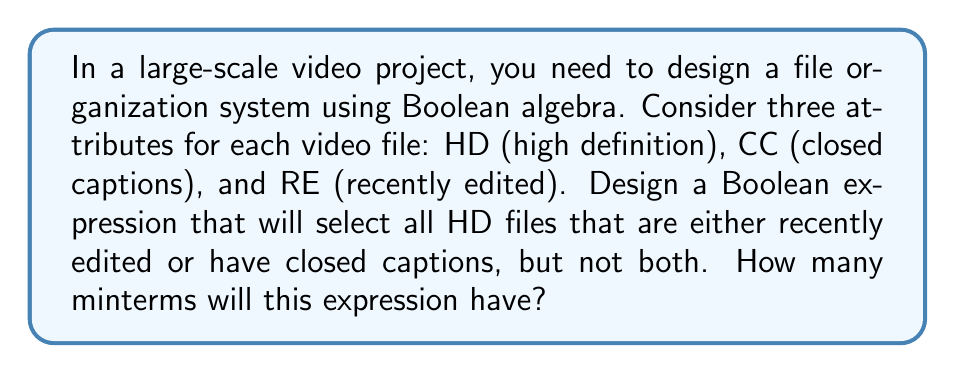Can you answer this question? Let's approach this step-by-step:

1) First, let's define our variables:
   HD: High Definition
   CC: Closed Captions
   RE: Recently Edited

2) We want files that are HD (so HD must be true) AND either RE or CC, but not both. This can be expressed as:

   $$ HD \cdot (RE \oplus CC) $$

   Where $\oplus$ represents the XOR operation.

3) To expand this, let's recall the XOR operation in terms of AND, OR, and NOT:

   $$ A \oplus B = (A \cdot \overline{B}) + (\overline{A} \cdot B) $$

4) Substituting this into our expression:

   $$ HD \cdot ((RE \cdot \overline{CC}) + (\overline{RE} \cdot CC)) $$

5) Expanding this using the distributive property:

   $$ (HD \cdot RE \cdot \overline{CC}) + (HD \cdot \overline{RE} \cdot CC) $$

6) This expression is now in sum-of-products (SOP) form. Each term in this sum is a minterm.

7) Counting the minterms:
   - $HD \cdot RE \cdot \overline{CC}$ is one minterm
   - $HD \cdot \overline{RE} \cdot CC$ is another minterm

Therefore, this expression has 2 minterms.
Answer: 2 